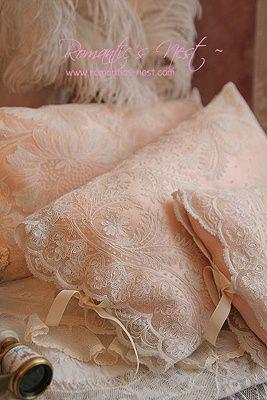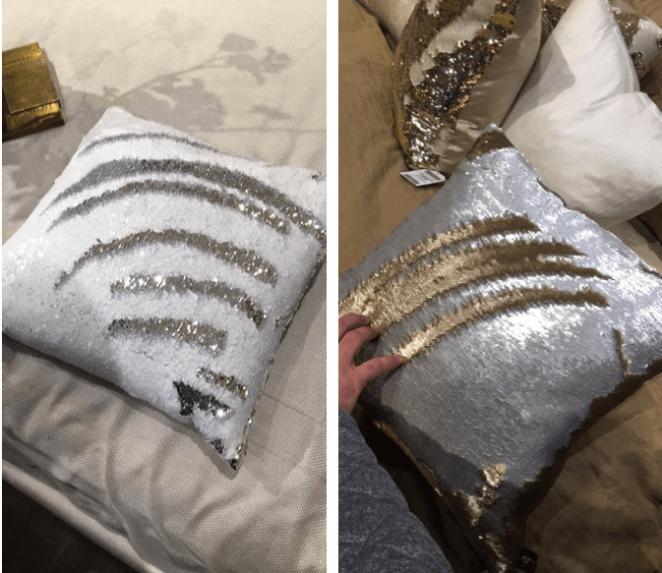The first image is the image on the left, the second image is the image on the right. Assess this claim about the two images: "In at least one image, a person is shown displaying fancy throw pillows.". Correct or not? Answer yes or no. No. 